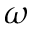Convert formula to latex. <formula><loc_0><loc_0><loc_500><loc_500>\omega</formula> 